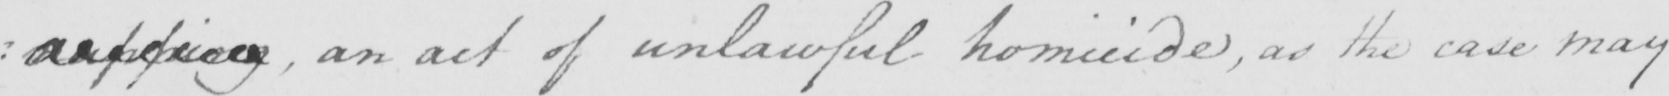Can you tell me what this handwritten text says? : napping an act of unlawful homicide , as the case may 